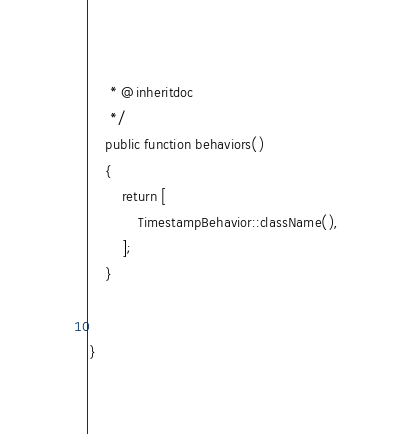Convert code to text. <code><loc_0><loc_0><loc_500><loc_500><_PHP_>     * @inheritdoc
     */
    public function behaviors()
    {
        return [
            TimestampBehavior::className(),
        ];
    }


}
</code> 